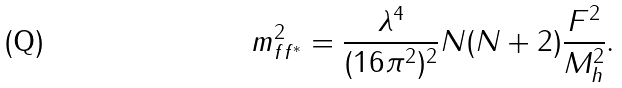Convert formula to latex. <formula><loc_0><loc_0><loc_500><loc_500>m ^ { 2 } _ { f f ^ { * } } = \frac { \lambda ^ { 4 } } { ( 1 6 \pi ^ { 2 } ) ^ { 2 } } N ( N + 2 ) \frac { F ^ { 2 } } { M _ { h } ^ { 2 } } .</formula> 